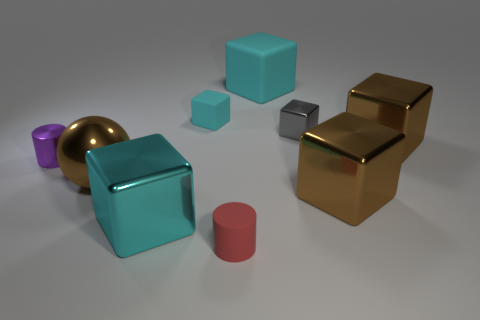Subtract all yellow balls. How many cyan cubes are left? 3 Subtract 1 blocks. How many blocks are left? 5 Subtract all gray cubes. How many cubes are left? 5 Subtract all large cyan matte cubes. How many cubes are left? 5 Subtract all yellow blocks. Subtract all brown cylinders. How many blocks are left? 6 Add 1 cyan rubber cylinders. How many objects exist? 10 Subtract all cylinders. How many objects are left? 7 Add 5 big balls. How many big balls exist? 6 Subtract 0 green cylinders. How many objects are left? 9 Subtract all large cyan metal objects. Subtract all metallic blocks. How many objects are left? 4 